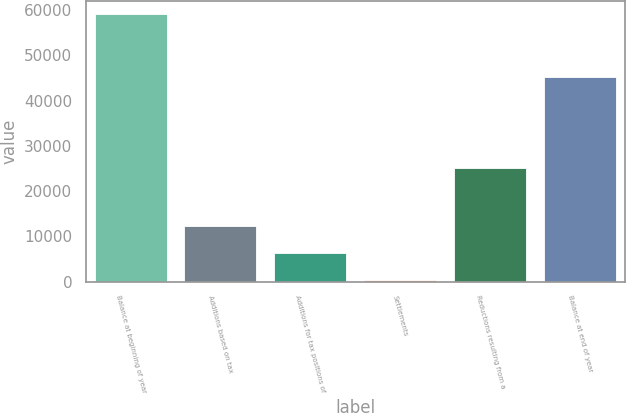Convert chart to OTSL. <chart><loc_0><loc_0><loc_500><loc_500><bar_chart><fcel>Balance at beginning of year<fcel>Additions based on tax<fcel>Additions for tax positions of<fcel>Settlements<fcel>Reductions resulting from a<fcel>Balance at end of year<nl><fcel>59190<fcel>12195.6<fcel>6321.3<fcel>447<fcel>25025<fcel>45201<nl></chart> 